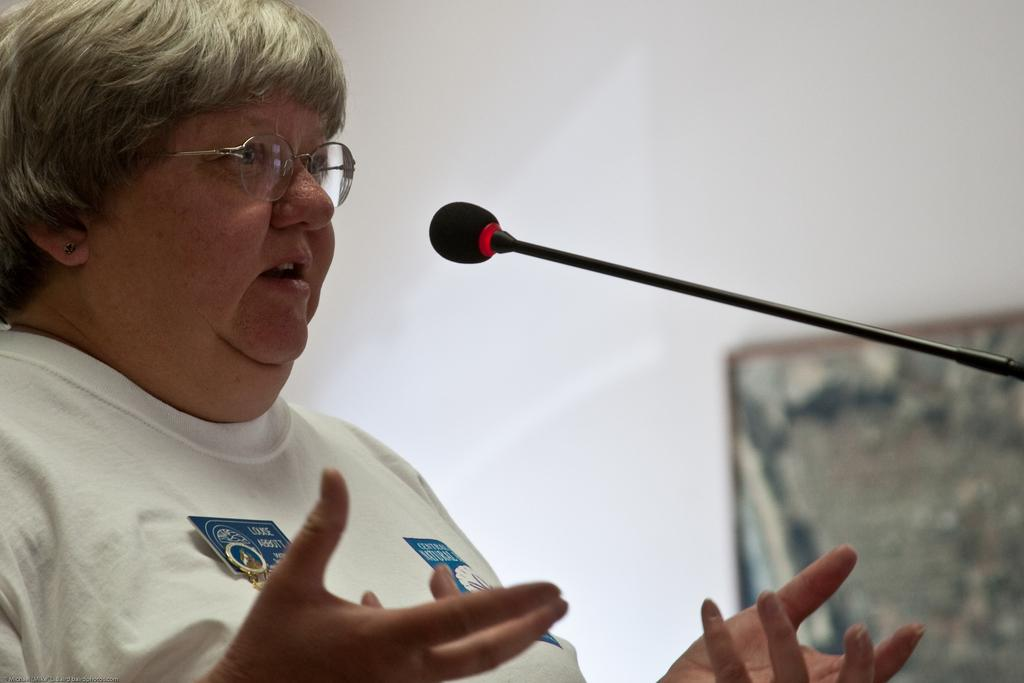What can be seen on the person in the image? There is a person with spectacles in the image. What object is visible in the image that is commonly used for amplifying sound? There is a microphone (mike) in the image. What is present in the background of the image that might be used for hanging pictures or decorations? There is a frame attached to the wall in the background of the image. What type of lunch is being served in the basket in the image? There is no basket or lunch present in the image. 